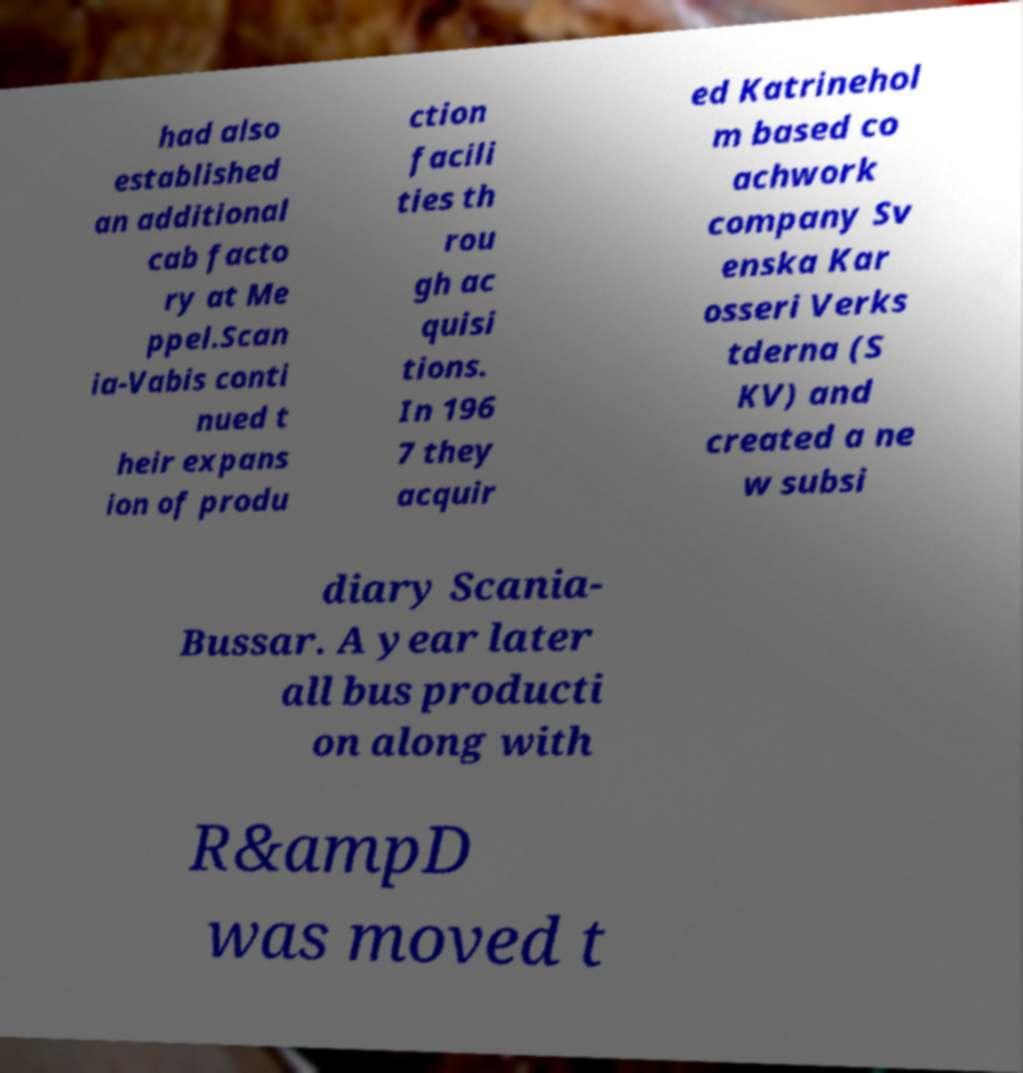Please read and relay the text visible in this image. What does it say? had also established an additional cab facto ry at Me ppel.Scan ia-Vabis conti nued t heir expans ion of produ ction facili ties th rou gh ac quisi tions. In 196 7 they acquir ed Katrinehol m based co achwork company Sv enska Kar osseri Verks tderna (S KV) and created a ne w subsi diary Scania- Bussar. A year later all bus producti on along with R&ampD was moved t 